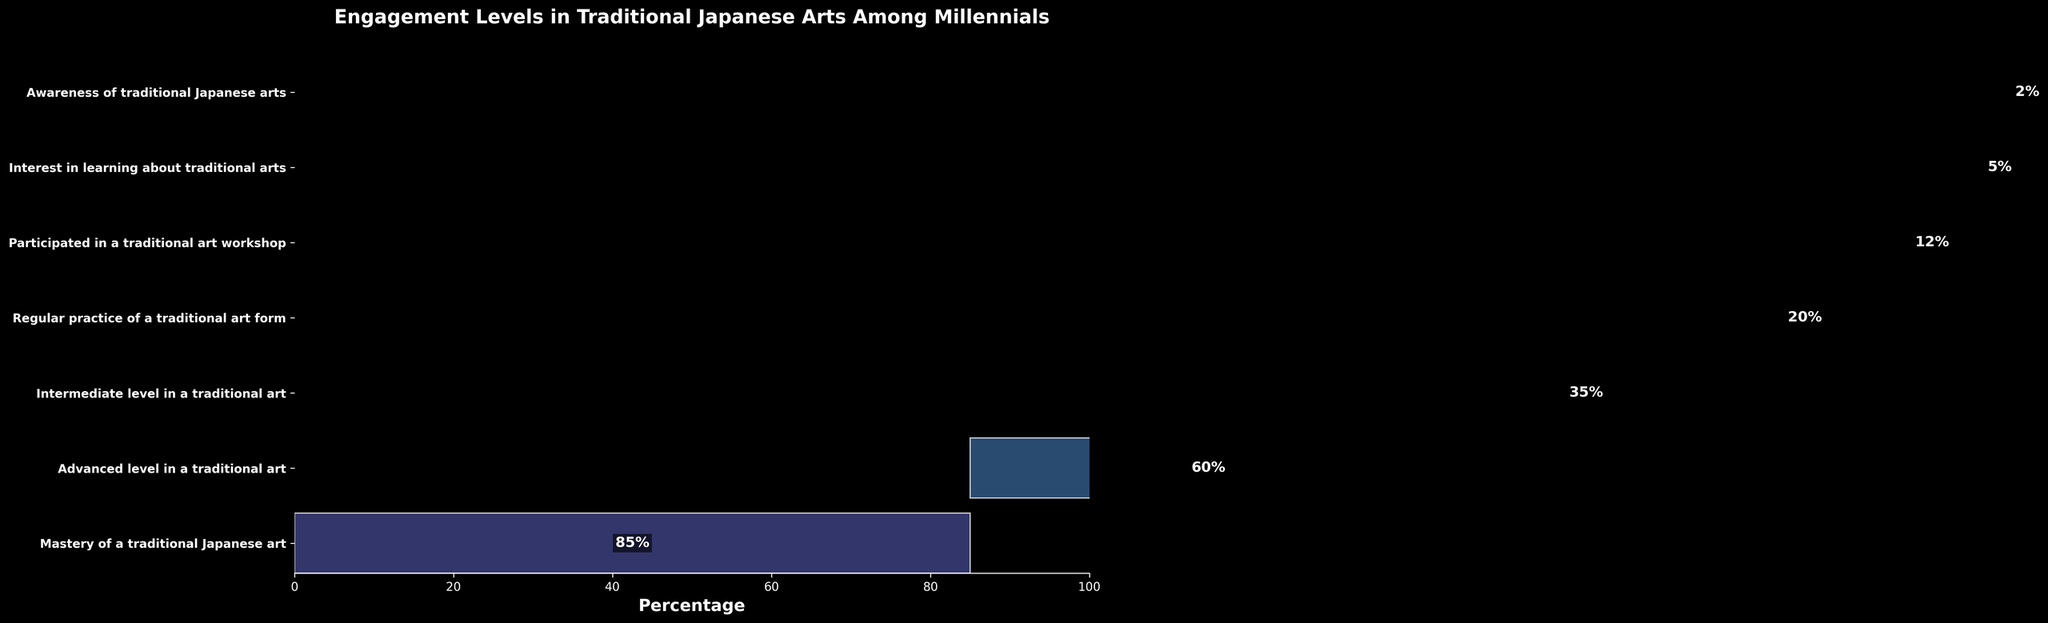What is the title of the chart? The title of the chart is located at the top and is meant to provide a summary of the content and purpose of the chart. By reading the title, we can understand what the chart refers to.
Answer: Engagement Levels in Traditional Japanese Arts Among Millennials How many engagement stages are shown in the chart? To identify the number of engagement stages, count the number of distinct stages listed along the y-axis.
Answer: 7 What is the percentage of millennials who participate in a traditional art workshop? Look for the stage labeled "Participated in a traditional art workshop" on the y-axis and read the corresponding percentage value.
Answer: 35% Which stage has the highest percentage? Identify the stage with the longest bar on the horizontal axis, indicating the highest percentage.
Answer: Awareness of traditional Japanese arts Is the percentage of millennials at an intermediate level higher or lower than those at an advanced level? Locate the bars corresponding to the stages "Intermediate level in a traditional art" and "Advanced level in a traditional art" and compare their lengths.
Answer: Higher What is the difference in percentage between those aware of traditional Japanese arts and those who have mastered a traditional Japanese art? Subtract the percentage of the mastery stage from the awareness stage.
Answer: 85% - 2% = 83% How many stages have percentages higher than 10%? Count the number of stages with percentage values greater than 10%.
Answer: 4 What percentage of millennials show interest in learning about traditional arts? Find the stage labeled "Interest in learning about traditional arts" on the y-axis and read the corresponding percentage value.
Answer: 60% Calculate the sum of the percentages for the stages from "Regular practice of a traditional art form" onwards. Sum the percentages for "Regular practice of a traditional art form", "Intermediate level in a traditional art", "Advanced level in a traditional art", and "Mastery of a traditional Japanese art". 20% + 12% + 5% + 2% = 39%
Answer: 39% What is the median percentage value among all the stages? Organize the percentage values in ascending order: [2, 5, 12, 20, 35, 60, 85]. The median value is the middle number in this ordered list.
Answer: 20% 